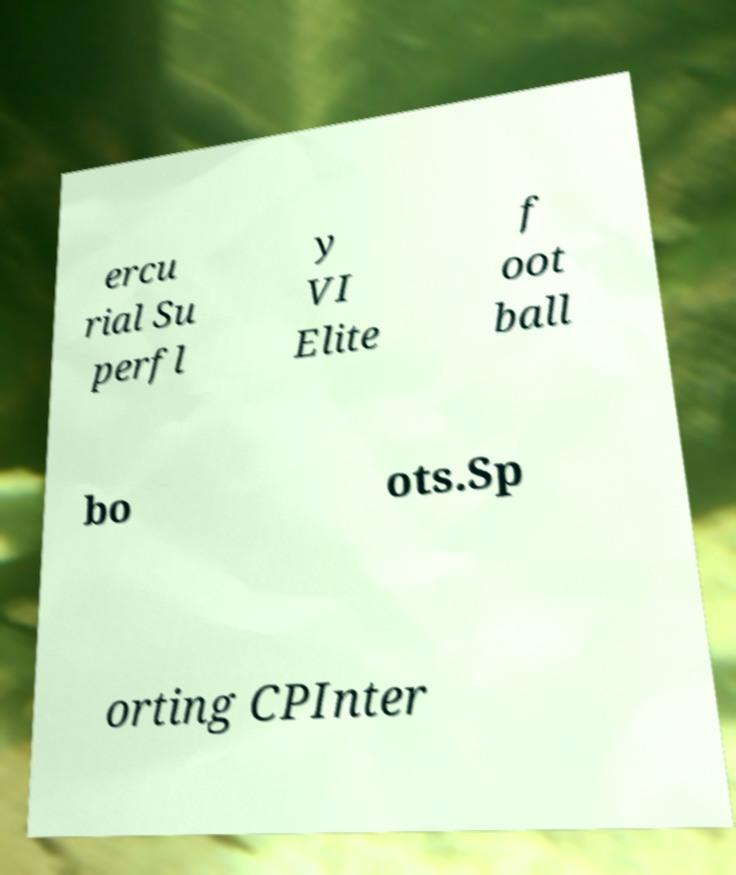What messages or text are displayed in this image? I need them in a readable, typed format. ercu rial Su perfl y VI Elite f oot ball bo ots.Sp orting CPInter 